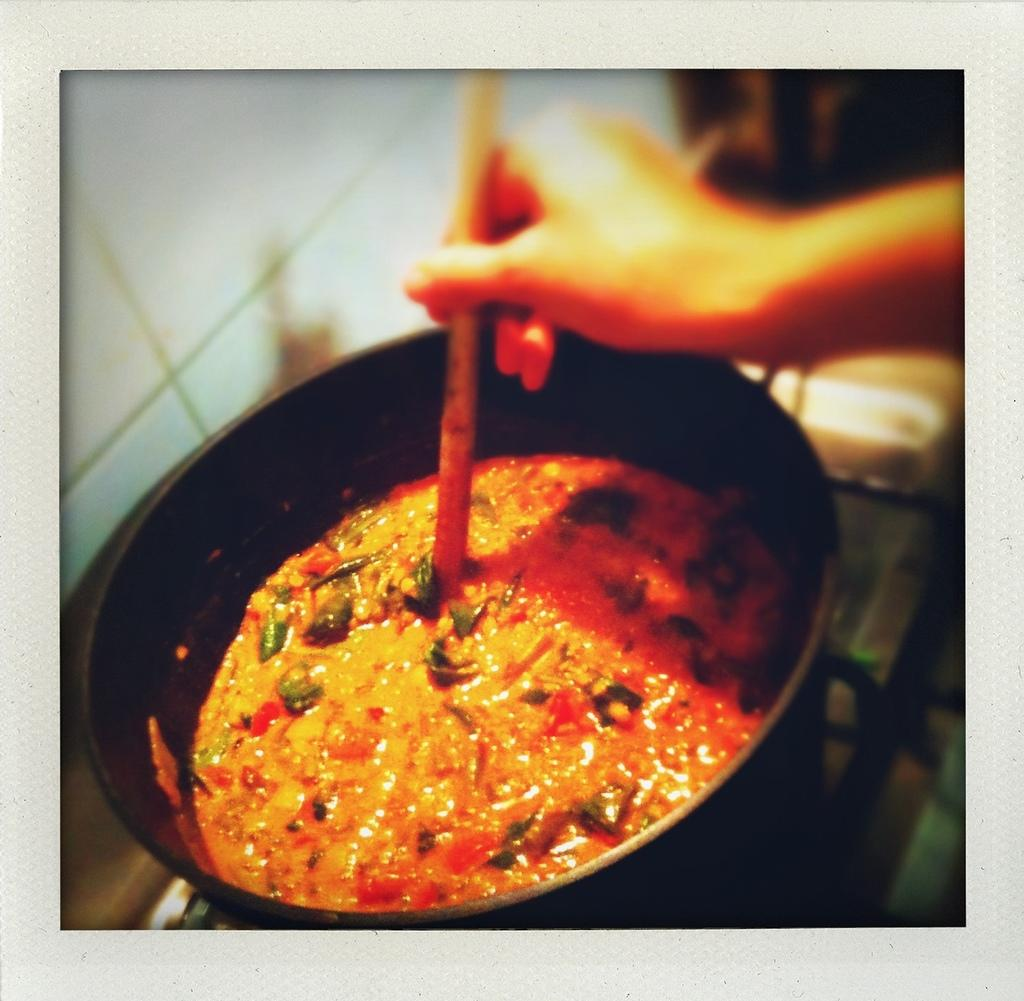What is the main object in the center of the image? There is a pan in the center of the image. What is inside the pan? The pan contains curry. Can you describe the hand and spoon in the image? There is a hand holding a spoon at the top side of the image. What type of key is being used to stir the curry in the image? There is no key present in the image; it is a hand holding a spoon that is being used to stir the curry. 